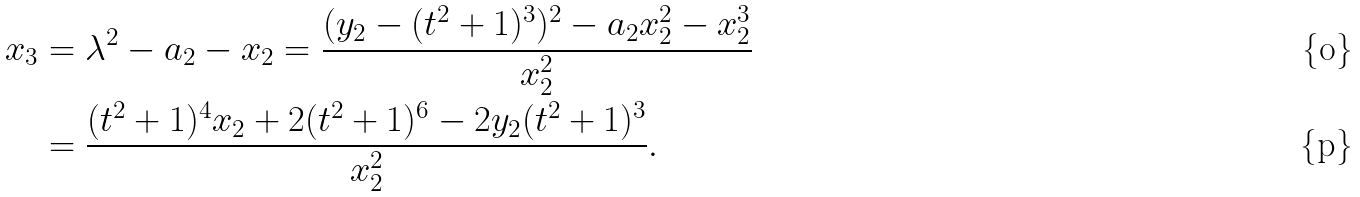<formula> <loc_0><loc_0><loc_500><loc_500>x _ { 3 } & = \lambda ^ { 2 } - a _ { 2 } - x _ { 2 } = \frac { ( y _ { 2 } - ( t ^ { 2 } + 1 ) ^ { 3 } ) ^ { 2 } - a _ { 2 } x _ { 2 } ^ { 2 } - x _ { 2 } ^ { 3 } } { x _ { 2 } ^ { 2 } } \\ & = \frac { ( t ^ { 2 } + 1 ) ^ { 4 } x _ { 2 } + 2 ( t ^ { 2 } + 1 ) ^ { 6 } - 2 y _ { 2 } ( t ^ { 2 } + 1 ) ^ { 3 } } { x _ { 2 } ^ { 2 } } .</formula> 